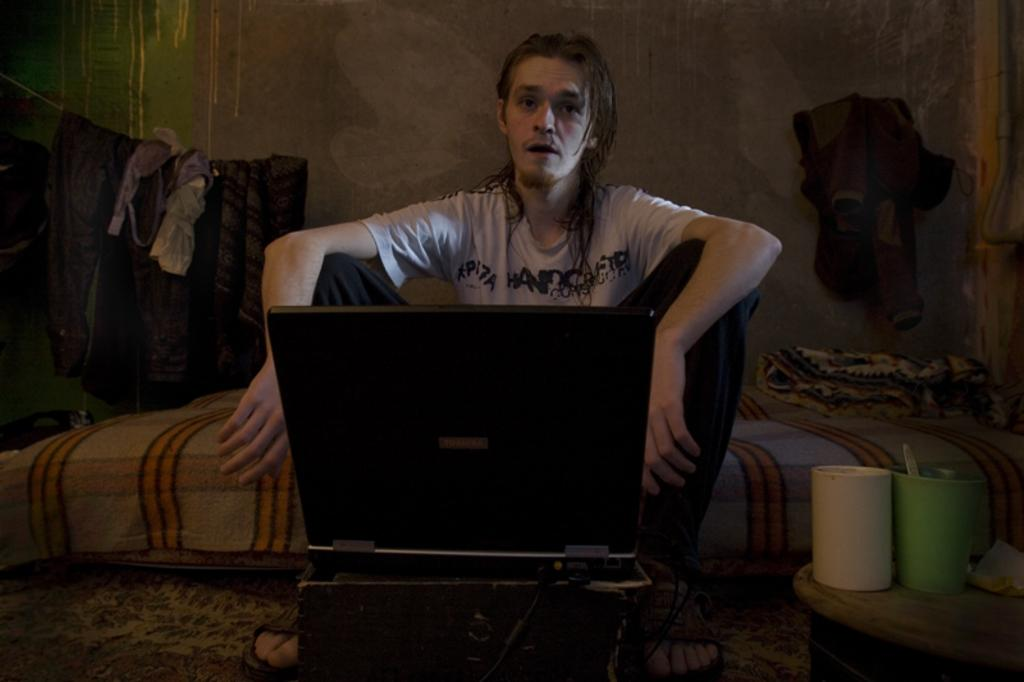What is the main subject of the image? There is a person in the image. What is the person wearing? The person is wearing a white t-shirt. What electronic device can be seen in the image? There is a laptop in the image. What objects are on the right side of the image? There are mugs on the right side of the image. What can be seen in the background of the image? Clothes are hanging on a rope in the background of the image. What type of grape is being used for the treatment in the image? There is no grape or treatment present in the image. Is the person in the image driving a vehicle? There is no indication in the image that the person is driving a vehicle. 